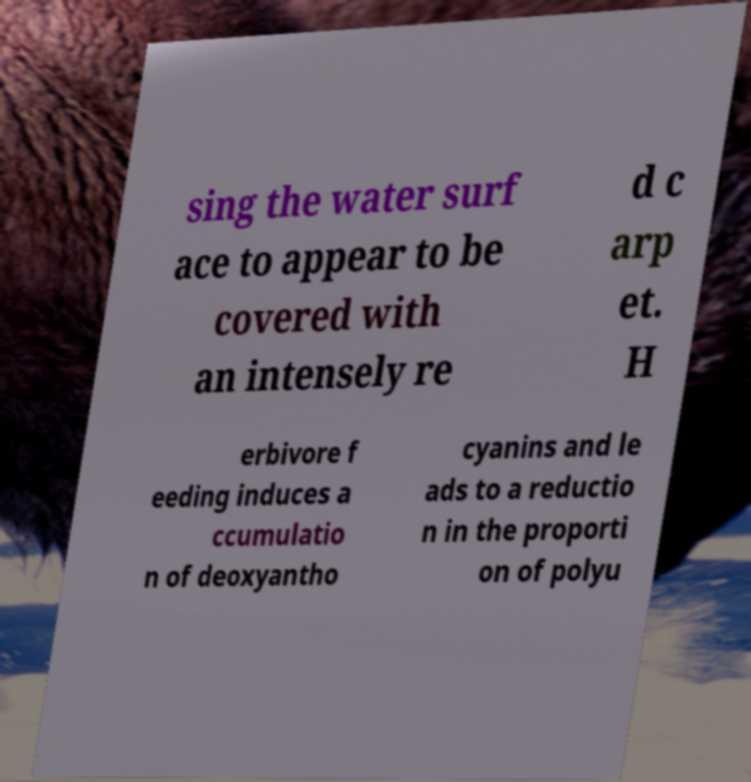Please identify and transcribe the text found in this image. sing the water surf ace to appear to be covered with an intensely re d c arp et. H erbivore f eeding induces a ccumulatio n of deoxyantho cyanins and le ads to a reductio n in the proporti on of polyu 